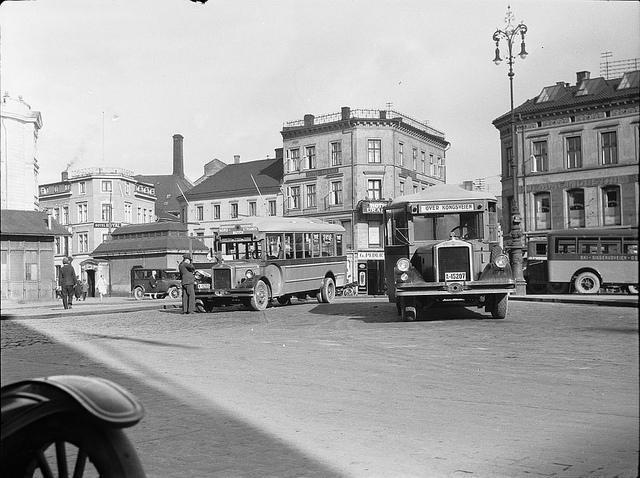How many buses are there?
Give a very brief answer. 3. 